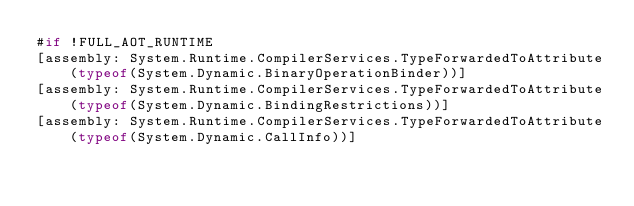Convert code to text. <code><loc_0><loc_0><loc_500><loc_500><_C#_>#if !FULL_AOT_RUNTIME
[assembly: System.Runtime.CompilerServices.TypeForwardedToAttribute(typeof(System.Dynamic.BinaryOperationBinder))]
[assembly: System.Runtime.CompilerServices.TypeForwardedToAttribute(typeof(System.Dynamic.BindingRestrictions))]
[assembly: System.Runtime.CompilerServices.TypeForwardedToAttribute(typeof(System.Dynamic.CallInfo))]</code> 